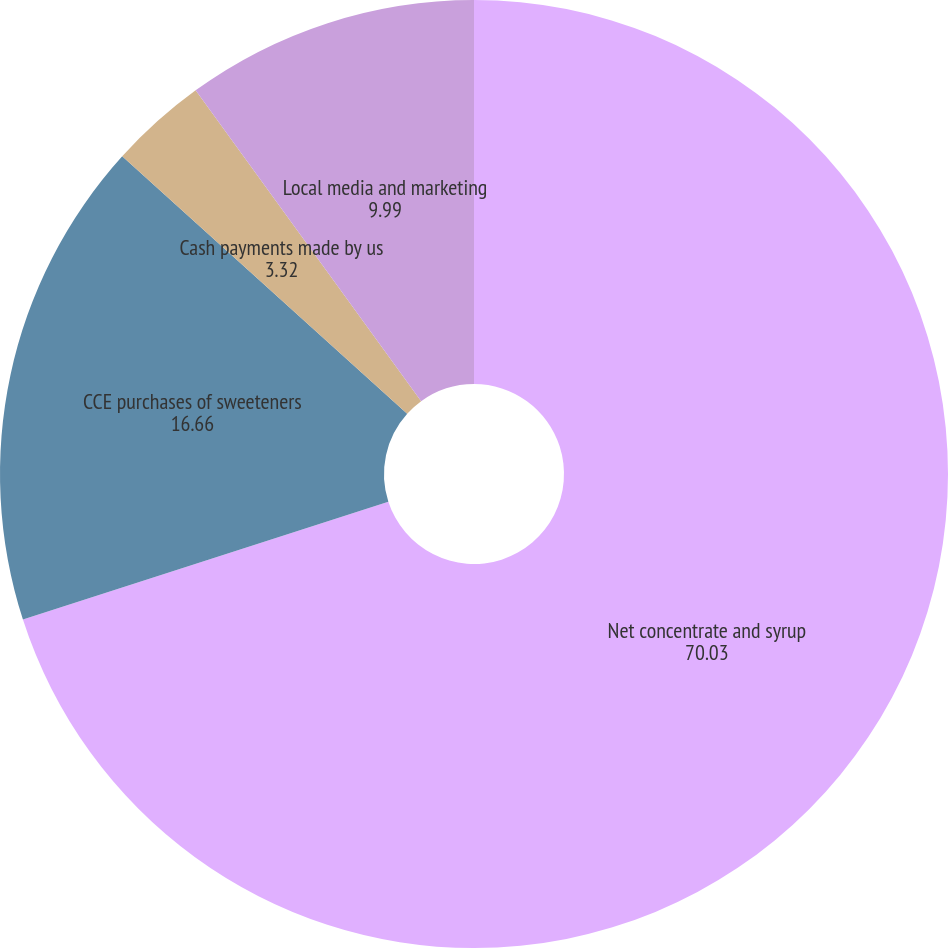Convert chart to OTSL. <chart><loc_0><loc_0><loc_500><loc_500><pie_chart><fcel>Net concentrate and syrup<fcel>CCE purchases of sweeteners<fcel>Cash payments made by us<fcel>Local media and marketing<nl><fcel>70.03%<fcel>16.66%<fcel>3.32%<fcel>9.99%<nl></chart> 